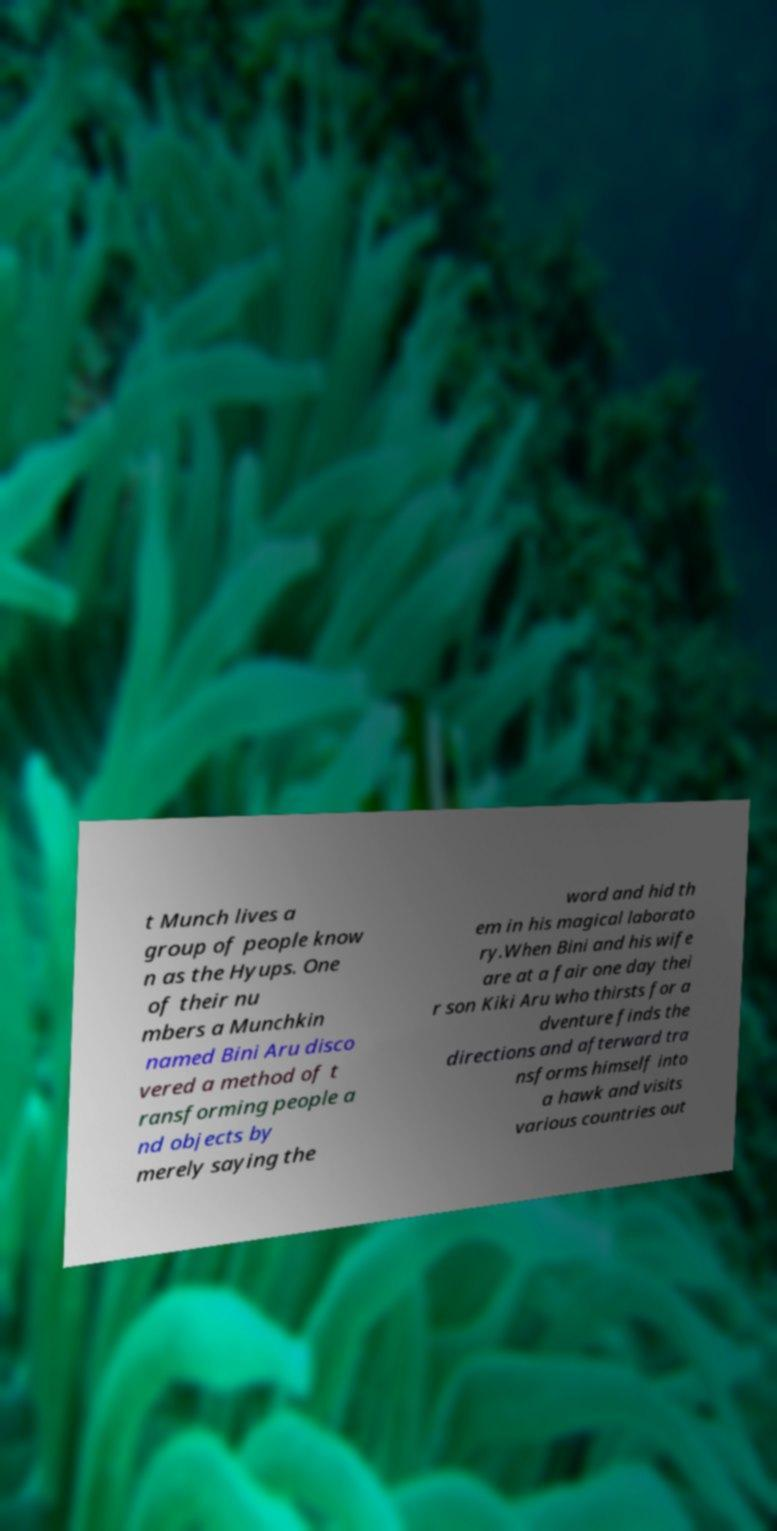Could you assist in decoding the text presented in this image and type it out clearly? t Munch lives a group of people know n as the Hyups. One of their nu mbers a Munchkin named Bini Aru disco vered a method of t ransforming people a nd objects by merely saying the word and hid th em in his magical laborato ry.When Bini and his wife are at a fair one day thei r son Kiki Aru who thirsts for a dventure finds the directions and afterward tra nsforms himself into a hawk and visits various countries out 